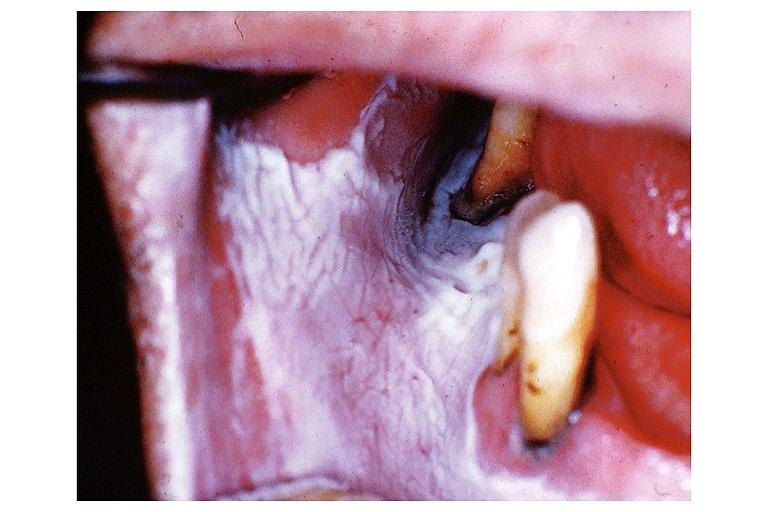does this image show leukoplakia?
Answer the question using a single word or phrase. Yes 